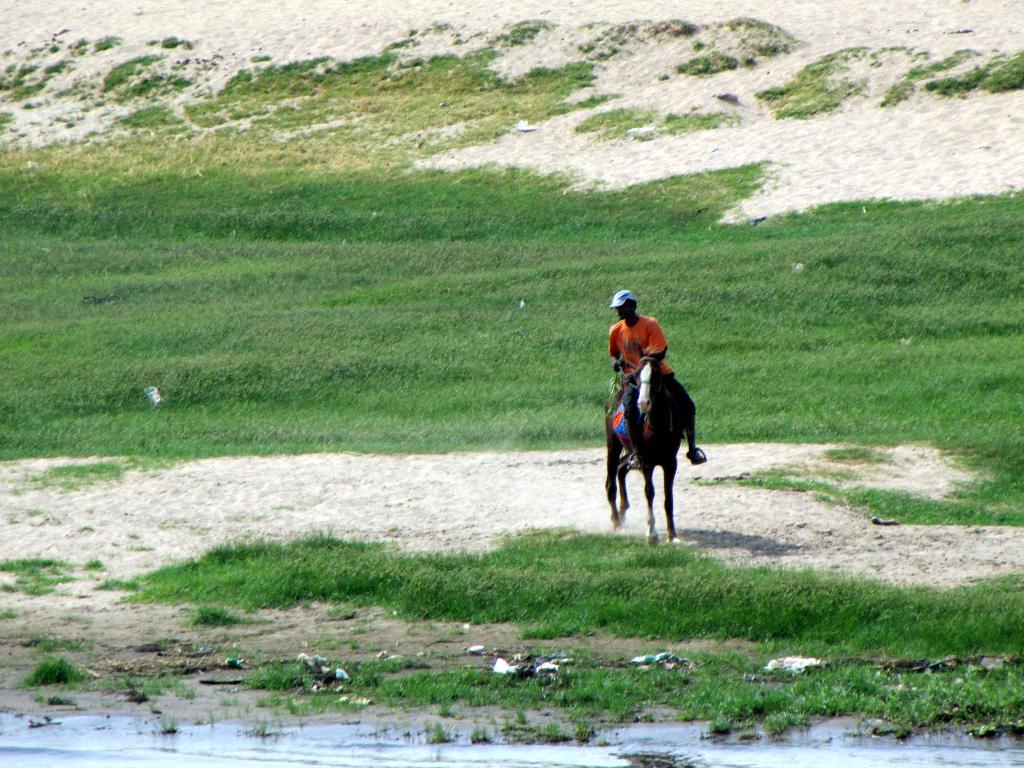What is the main subject of the image? There is a man in the image. What is the man doing in the image? The man is sitting on a horse. What type of terrain can be seen in the image? There is grass and sand on the ground. What can be seen in the background of the image? There is water visible from left to right in the image. What book is the snail reading in the image? There is no snail or book present in the image. How is the man dividing the water in the image? There is no division of water taking place in the image; the man is simply sitting on a horse with water visible in the background. 